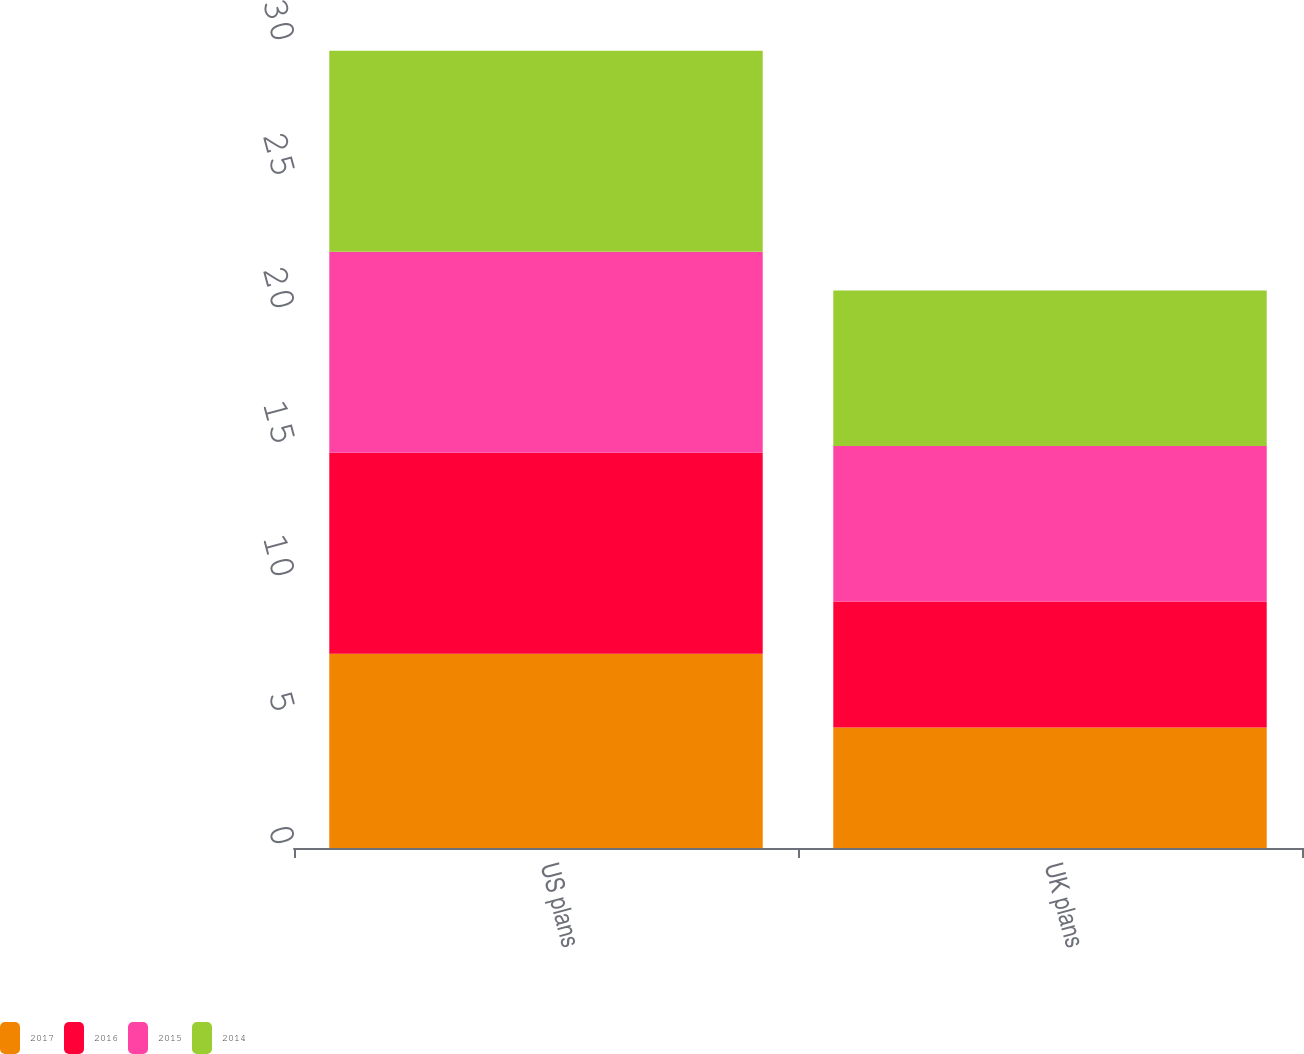Convert chart. <chart><loc_0><loc_0><loc_500><loc_500><stacked_bar_chart><ecel><fcel>US plans<fcel>UK plans<nl><fcel>2017<fcel>7.25<fcel>4.5<nl><fcel>2016<fcel>7.5<fcel>4.7<nl><fcel>2015<fcel>7.5<fcel>5.8<nl><fcel>2014<fcel>7.5<fcel>5.8<nl></chart> 